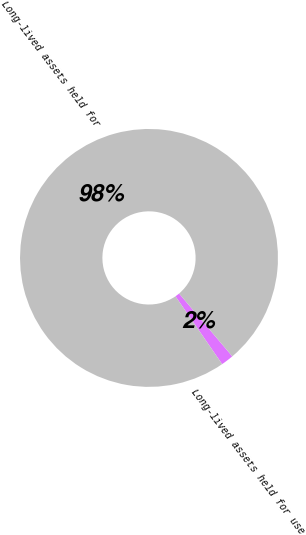<chart> <loc_0><loc_0><loc_500><loc_500><pie_chart><fcel>Long-lived assets held for use<fcel>Long-lived assets held for<nl><fcel>1.58%<fcel>98.42%<nl></chart> 